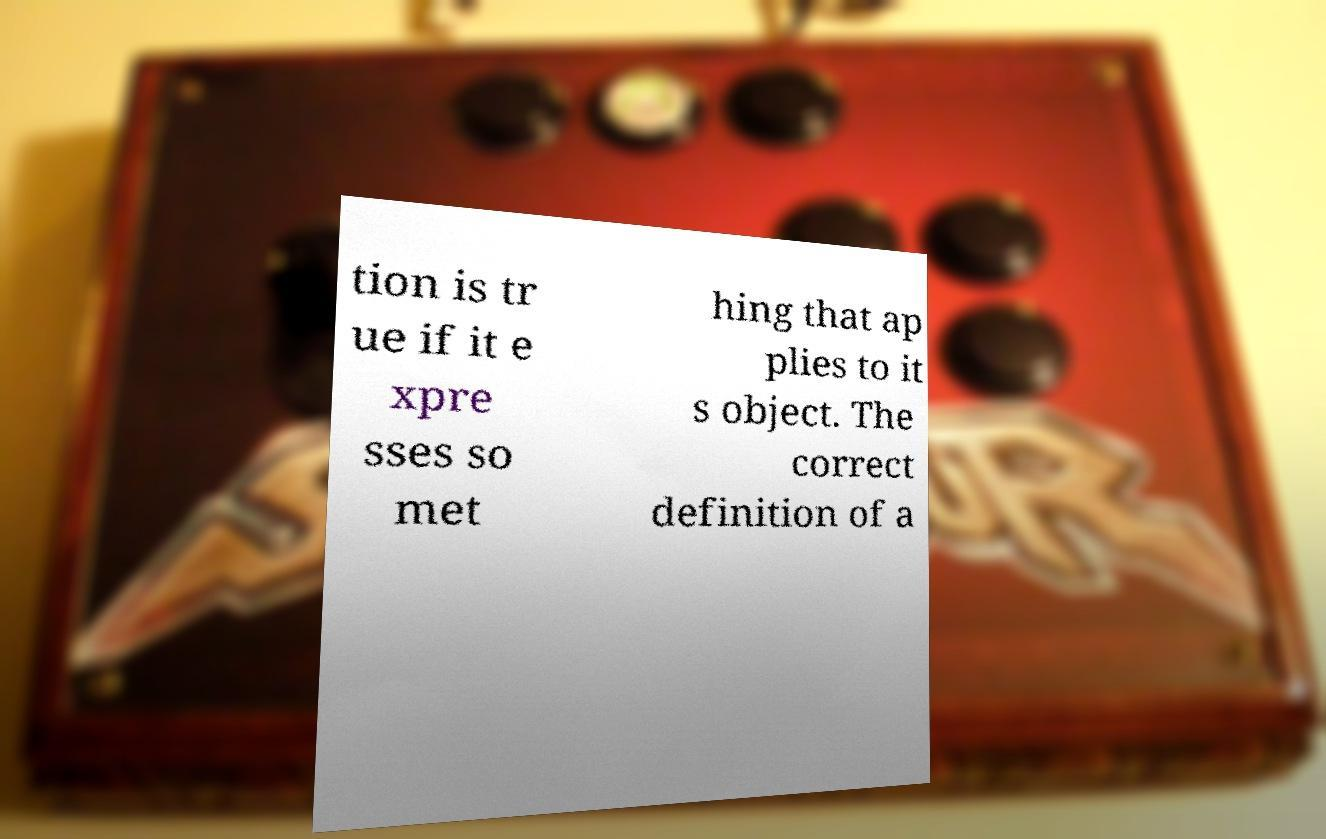Can you read and provide the text displayed in the image?This photo seems to have some interesting text. Can you extract and type it out for me? tion is tr ue if it e xpre sses so met hing that ap plies to it s object. The correct definition of a 